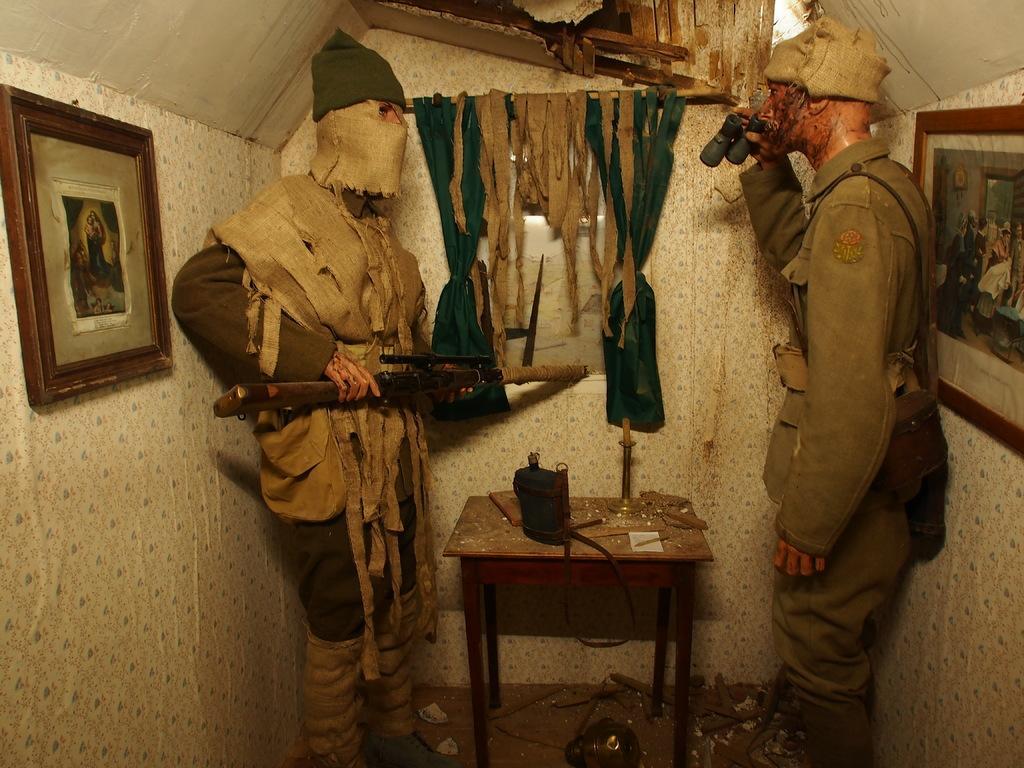Can you describe this image briefly? There are two people standing. One person is holding weapon in his hand and the other person is holding binoculars. I think these two are statues. This is a small table with an object on it. These are the photo frames attached to the walls. This looks like a curtain hanging to the hanger. I can see few particles on the floor. This is a broken rooftop. 